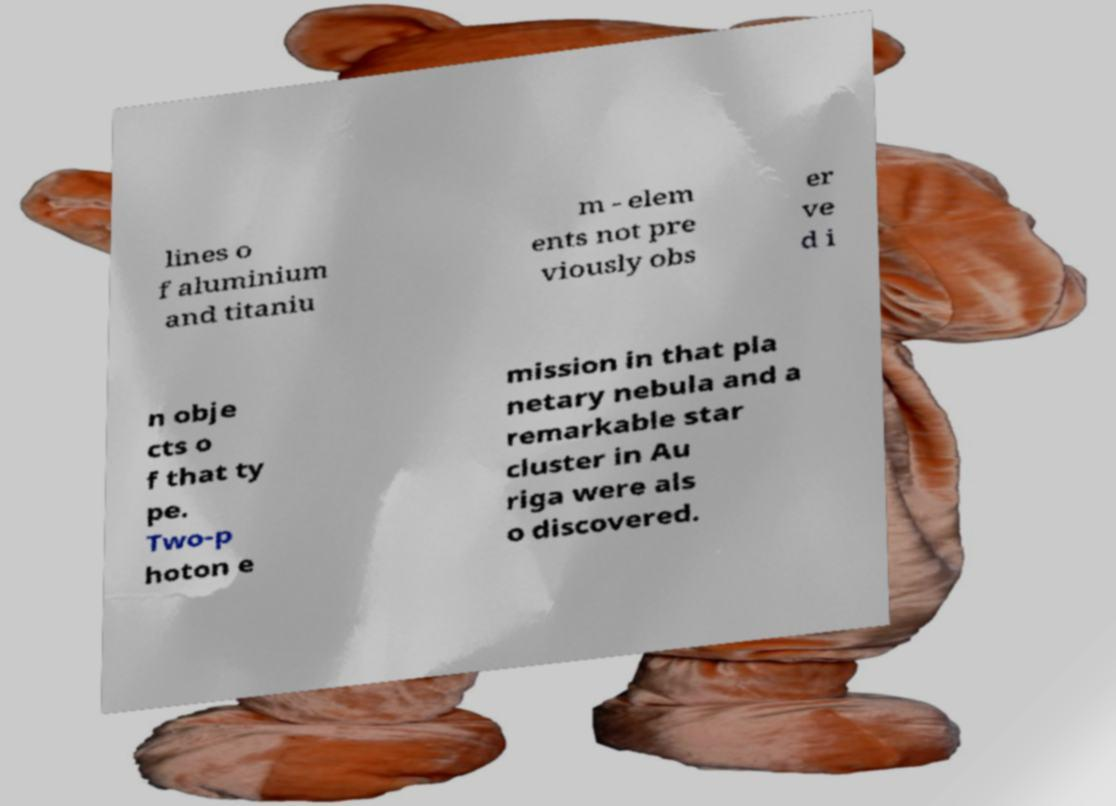I need the written content from this picture converted into text. Can you do that? lines o f aluminium and titaniu m - elem ents not pre viously obs er ve d i n obje cts o f that ty pe. Two-p hoton e mission in that pla netary nebula and a remarkable star cluster in Au riga were als o discovered. 